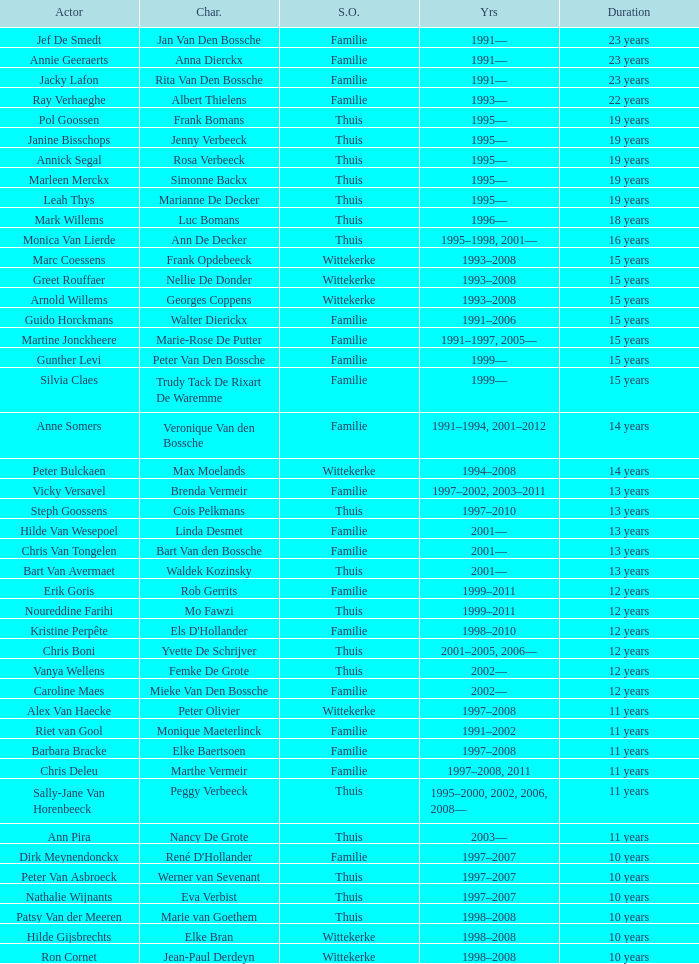For 13 years, what part did vicky versavel perform? Brenda Vermeir. 